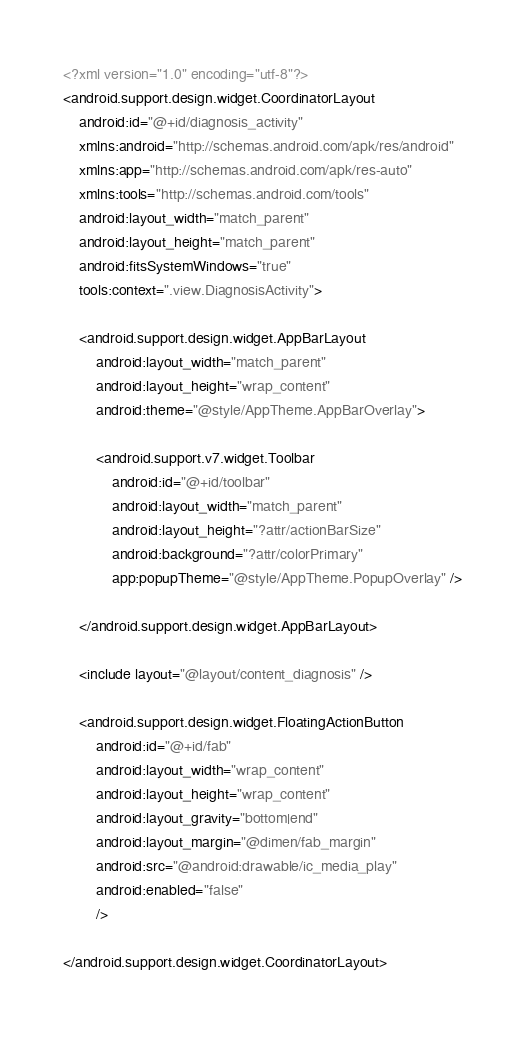Convert code to text. <code><loc_0><loc_0><loc_500><loc_500><_XML_><?xml version="1.0" encoding="utf-8"?>
<android.support.design.widget.CoordinatorLayout
    android:id="@+id/diagnosis_activity"
    xmlns:android="http://schemas.android.com/apk/res/android"
    xmlns:app="http://schemas.android.com/apk/res-auto"
    xmlns:tools="http://schemas.android.com/tools"
    android:layout_width="match_parent"
    android:layout_height="match_parent"
    android:fitsSystemWindows="true"
    tools:context=".view.DiagnosisActivity">

    <android.support.design.widget.AppBarLayout
        android:layout_width="match_parent"
        android:layout_height="wrap_content"
        android:theme="@style/AppTheme.AppBarOverlay">

        <android.support.v7.widget.Toolbar
            android:id="@+id/toolbar"
            android:layout_width="match_parent"
            android:layout_height="?attr/actionBarSize"
            android:background="?attr/colorPrimary"
            app:popupTheme="@style/AppTheme.PopupOverlay" />

    </android.support.design.widget.AppBarLayout>

    <include layout="@layout/content_diagnosis" />

    <android.support.design.widget.FloatingActionButton
        android:id="@+id/fab"
        android:layout_width="wrap_content"
        android:layout_height="wrap_content"
        android:layout_gravity="bottom|end"
        android:layout_margin="@dimen/fab_margin"
        android:src="@android:drawable/ic_media_play"
        android:enabled="false"
        />

</android.support.design.widget.CoordinatorLayout>
</code> 